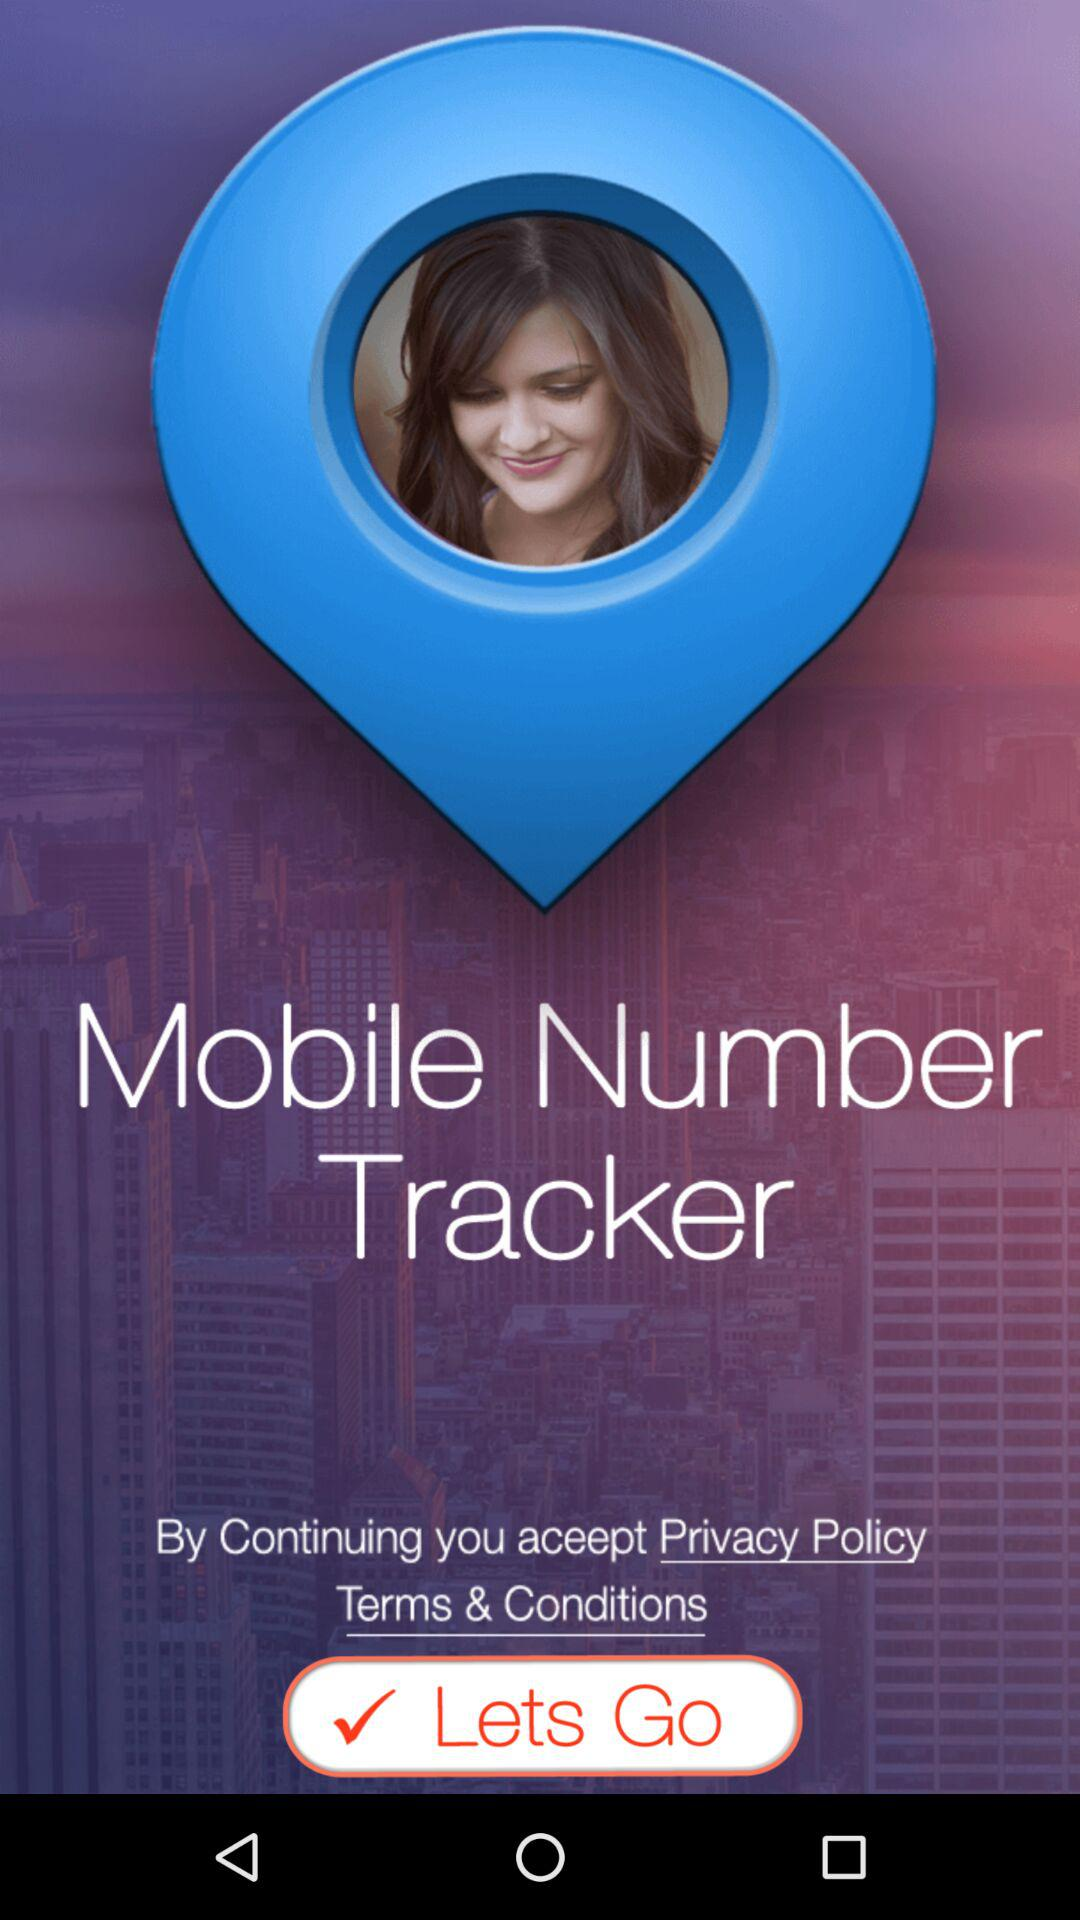What is the name of the application? The name of the application is "Mobile Number Tracker". 